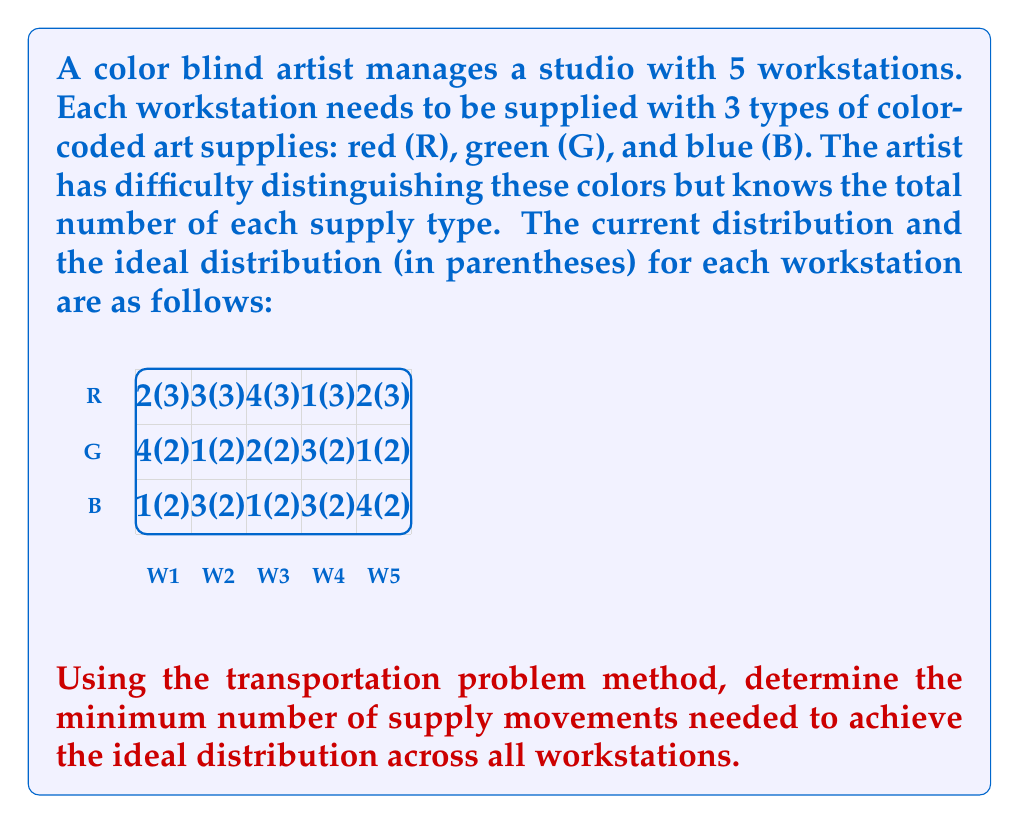Can you answer this question? To solve this problem, we'll use the transportation problem method:

1) First, let's create a table of the current distribution (supply) and the ideal distribution (demand):

   W1   W2   W3   W4   W5   Supply
R  2    3    4    1    2    12
G  4    1    2    3    1    11
B  1    3    1    3    4    12
D  7    7    7    7    7    35

2) Calculate the total supply and demand:
   Total Supply = 12 + 11 + 12 = 35
   Total Demand = 7 + 7 + 7 + 7 + 7 = 35
   
   Since supply equals demand, this is a balanced transportation problem.

3) Now, let's create a table showing the differences between current and ideal distribution:

   W1   W2   W3   W4   W5
R -1    0   +1   -2   -1
G +2   -1    0   +1   -1
B -1   +1   -1   +1   +2

4) We'll use the Vogel's Approximation Method (VAM) to find the initial feasible solution:

   Step 1: Calculate row and column penalties
   Step 2: Select the highest penalty and allocate maximum possible in the least cost cell of that row/column
   Step 3: Adjust the supply and demand, and repeat until all allocations are made

5) After applying VAM, we get the following allocation:

   W1   W2   W3   W4   W5
R  2    3    3    1    3
G  2    2    2    3    2
B  3    2    2    3    2

6) Now, we calculate the number of movements:
   R: |2-3| + |3-3| + |4-3| + |1-3| + |2-3| = 1 + 0 + 1 + 2 + 1 = 5
   G: |4-2| + |1-2| + |2-2| + |3-2| + |1-2| = 2 + 1 + 0 + 1 + 1 = 5
   B: |1-3| + |3-2| + |1-2| + |3-3| + |4-2| = 2 + 1 + 1 + 0 + 2 = 6

7) The total number of movements is the sum of these: 5 + 5 + 6 = 16

Therefore, the minimum number of supply movements needed is 16.
Answer: 16 movements 